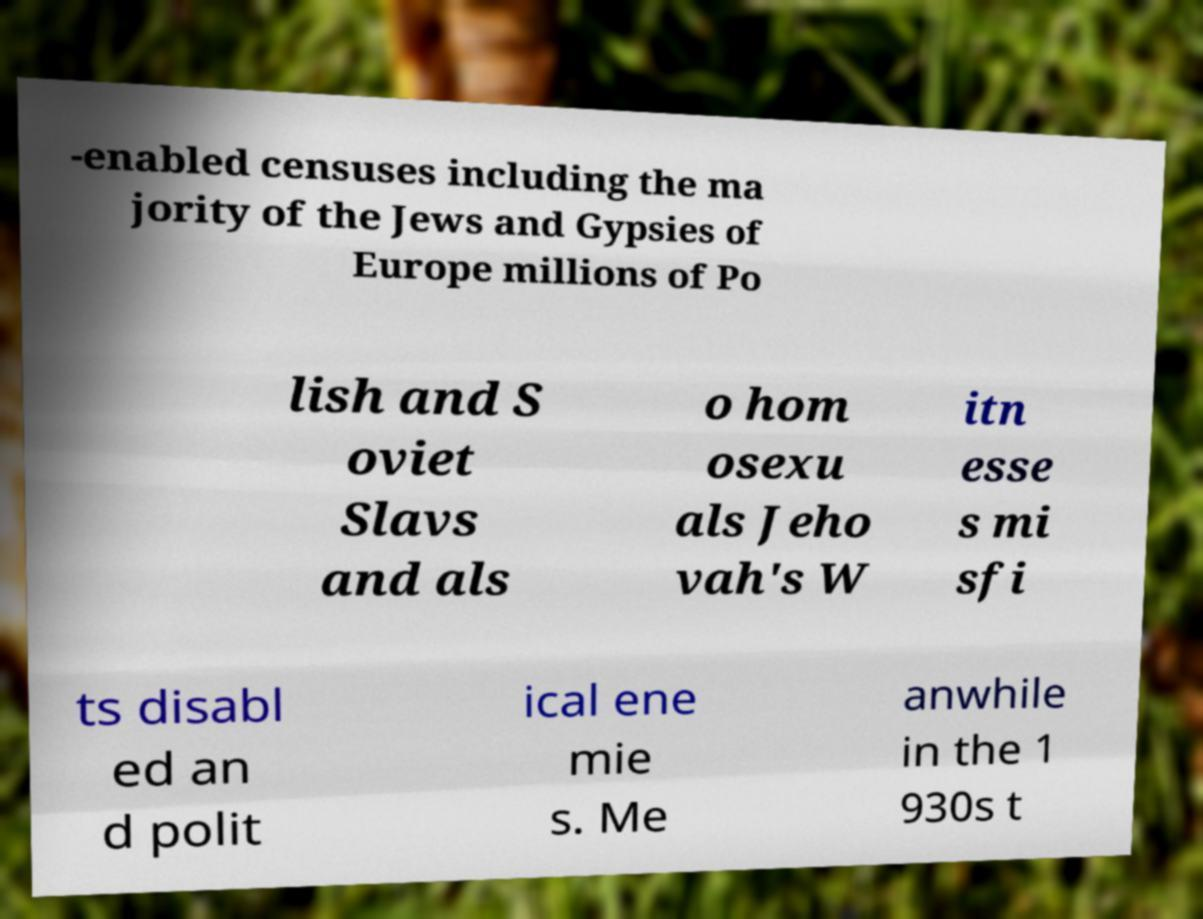Could you extract and type out the text from this image? -enabled censuses including the ma jority of the Jews and Gypsies of Europe millions of Po lish and S oviet Slavs and als o hom osexu als Jeho vah's W itn esse s mi sfi ts disabl ed an d polit ical ene mie s. Me anwhile in the 1 930s t 